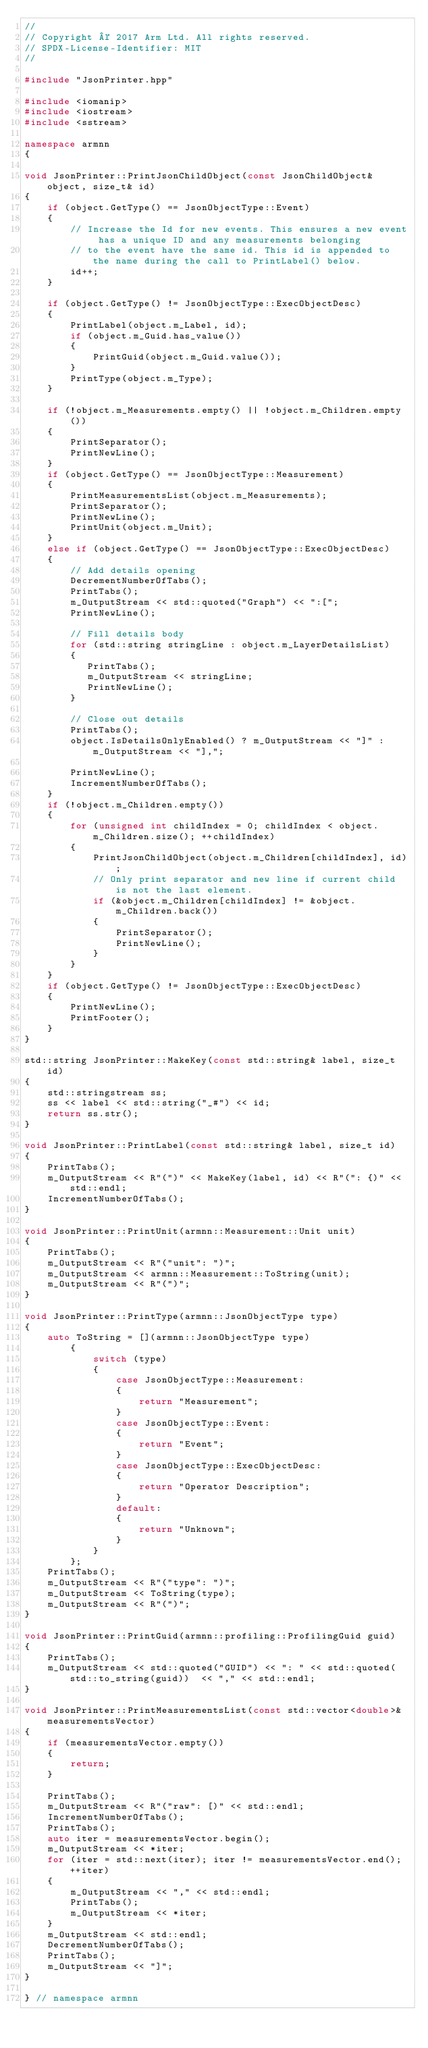Convert code to text. <code><loc_0><loc_0><loc_500><loc_500><_C++_>//
// Copyright © 2017 Arm Ltd. All rights reserved.
// SPDX-License-Identifier: MIT
//

#include "JsonPrinter.hpp"

#include <iomanip>
#include <iostream>
#include <sstream>

namespace armnn
{

void JsonPrinter::PrintJsonChildObject(const JsonChildObject& object, size_t& id)
{
    if (object.GetType() == JsonObjectType::Event)
    {
        // Increase the Id for new events. This ensures a new event has a unique ID and any measurements belonging
        // to the event have the same id. This id is appended to the name during the call to PrintLabel() below.
        id++;
    }

    if (object.GetType() != JsonObjectType::ExecObjectDesc)
    {
        PrintLabel(object.m_Label, id);
        if (object.m_Guid.has_value())
        {
            PrintGuid(object.m_Guid.value());
        }
        PrintType(object.m_Type);
    }

    if (!object.m_Measurements.empty() || !object.m_Children.empty())
    {
        PrintSeparator();
        PrintNewLine();
    }
    if (object.GetType() == JsonObjectType::Measurement)
    {
        PrintMeasurementsList(object.m_Measurements);
        PrintSeparator();
        PrintNewLine();
        PrintUnit(object.m_Unit);
    }
    else if (object.GetType() == JsonObjectType::ExecObjectDesc)
    {
        // Add details opening
        DecrementNumberOfTabs();
        PrintTabs();
        m_OutputStream << std::quoted("Graph") << ":[";
        PrintNewLine();

        // Fill details body
        for (std::string stringLine : object.m_LayerDetailsList)
        {
           PrintTabs();
           m_OutputStream << stringLine;
           PrintNewLine();
        }

        // Close out details
        PrintTabs();
        object.IsDetailsOnlyEnabled() ? m_OutputStream << "]" : m_OutputStream << "],";

        PrintNewLine();
        IncrementNumberOfTabs();
    }
    if (!object.m_Children.empty())
    {
        for (unsigned int childIndex = 0; childIndex < object.m_Children.size(); ++childIndex)
        {
            PrintJsonChildObject(object.m_Children[childIndex], id);
            // Only print separator and new line if current child is not the last element.
            if (&object.m_Children[childIndex] != &object.m_Children.back())
            {
                PrintSeparator();
                PrintNewLine();
            }
        }
    }
    if (object.GetType() != JsonObjectType::ExecObjectDesc)
    {
        PrintNewLine();
        PrintFooter();
    }
}

std::string JsonPrinter::MakeKey(const std::string& label, size_t id)
{
    std::stringstream ss;
    ss << label << std::string("_#") << id;
    return ss.str();
}

void JsonPrinter::PrintLabel(const std::string& label, size_t id)
{
    PrintTabs();
    m_OutputStream << R"(")" << MakeKey(label, id) << R"(": {)" << std::endl;
    IncrementNumberOfTabs();
}

void JsonPrinter::PrintUnit(armnn::Measurement::Unit unit)
{
    PrintTabs();
    m_OutputStream << R"("unit": ")";
    m_OutputStream << armnn::Measurement::ToString(unit);
    m_OutputStream << R"(")";
}

void JsonPrinter::PrintType(armnn::JsonObjectType type)
{
    auto ToString = [](armnn::JsonObjectType type)
        {
            switch (type)
            {
                case JsonObjectType::Measurement:
                {
                    return "Measurement";
                }
                case JsonObjectType::Event:
                {
                    return "Event";
                }
                case JsonObjectType::ExecObjectDesc:
                {
                    return "Operator Description";
                }
                default:
                {
                    return "Unknown";
                }
            }
        };
    PrintTabs();
    m_OutputStream << R"("type": ")";
    m_OutputStream << ToString(type);
    m_OutputStream << R"(")";
}

void JsonPrinter::PrintGuid(armnn::profiling::ProfilingGuid guid)
{
    PrintTabs();
    m_OutputStream << std::quoted("GUID") << ": " << std::quoted(std::to_string(guid))  << "," << std::endl;
}

void JsonPrinter::PrintMeasurementsList(const std::vector<double>& measurementsVector)
{
    if (measurementsVector.empty())
    {
        return;
    }

    PrintTabs();
    m_OutputStream << R"("raw": [)" << std::endl;
    IncrementNumberOfTabs();
    PrintTabs();
    auto iter = measurementsVector.begin();
    m_OutputStream << *iter;
    for (iter = std::next(iter); iter != measurementsVector.end(); ++iter)
    {
        m_OutputStream << "," << std::endl;
        PrintTabs();
        m_OutputStream << *iter;
    }
    m_OutputStream << std::endl;
    DecrementNumberOfTabs();
    PrintTabs();
    m_OutputStream << "]";
}

} // namespace armnn</code> 